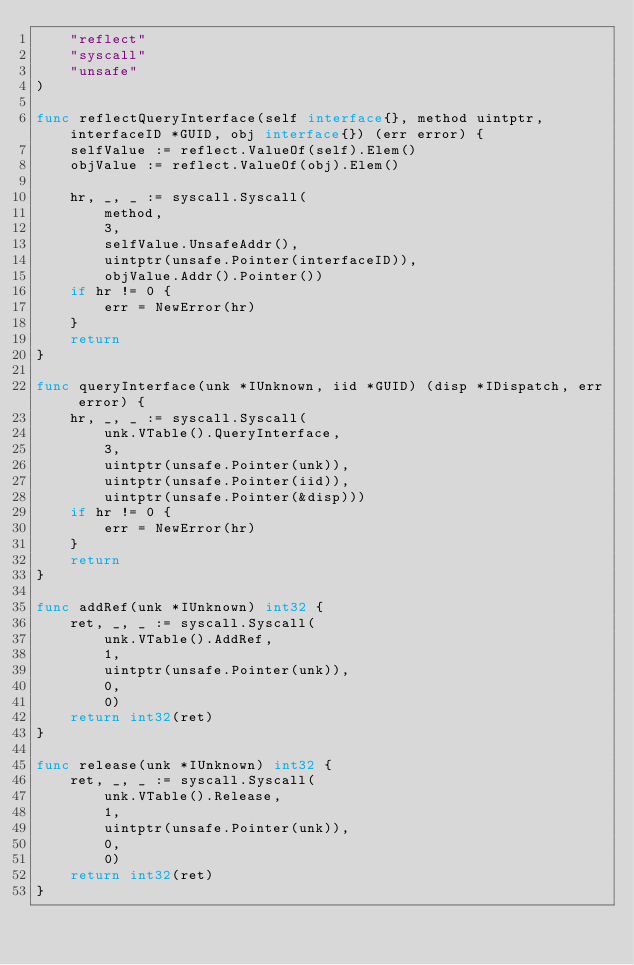Convert code to text. <code><loc_0><loc_0><loc_500><loc_500><_Go_>	"reflect"
	"syscall"
	"unsafe"
)

func reflectQueryInterface(self interface{}, method uintptr, interfaceID *GUID, obj interface{}) (err error) {
	selfValue := reflect.ValueOf(self).Elem()
	objValue := reflect.ValueOf(obj).Elem()

	hr, _, _ := syscall.Syscall(
		method,
		3,
		selfValue.UnsafeAddr(),
		uintptr(unsafe.Pointer(interfaceID)),
		objValue.Addr().Pointer())
	if hr != 0 {
		err = NewError(hr)
	}
	return
}

func queryInterface(unk *IUnknown, iid *GUID) (disp *IDispatch, err error) {
	hr, _, _ := syscall.Syscall(
		unk.VTable().QueryInterface,
		3,
		uintptr(unsafe.Pointer(unk)),
		uintptr(unsafe.Pointer(iid)),
		uintptr(unsafe.Pointer(&disp)))
	if hr != 0 {
		err = NewError(hr)
	}
	return
}

func addRef(unk *IUnknown) int32 {
	ret, _, _ := syscall.Syscall(
		unk.VTable().AddRef,
		1,
		uintptr(unsafe.Pointer(unk)),
		0,
		0)
	return int32(ret)
}

func release(unk *IUnknown) int32 {
	ret, _, _ := syscall.Syscall(
		unk.VTable().Release,
		1,
		uintptr(unsafe.Pointer(unk)),
		0,
		0)
	return int32(ret)
}
</code> 